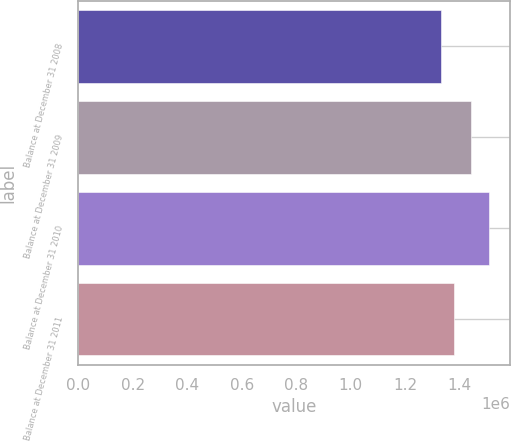Convert chart to OTSL. <chart><loc_0><loc_0><loc_500><loc_500><bar_chart><fcel>Balance at December 31 2008<fcel>Balance at December 31 2009<fcel>Balance at December 31 2010<fcel>Balance at December 31 2011<nl><fcel>1.33214e+06<fcel>1.44176e+06<fcel>1.50921e+06<fcel>1.38012e+06<nl></chart> 